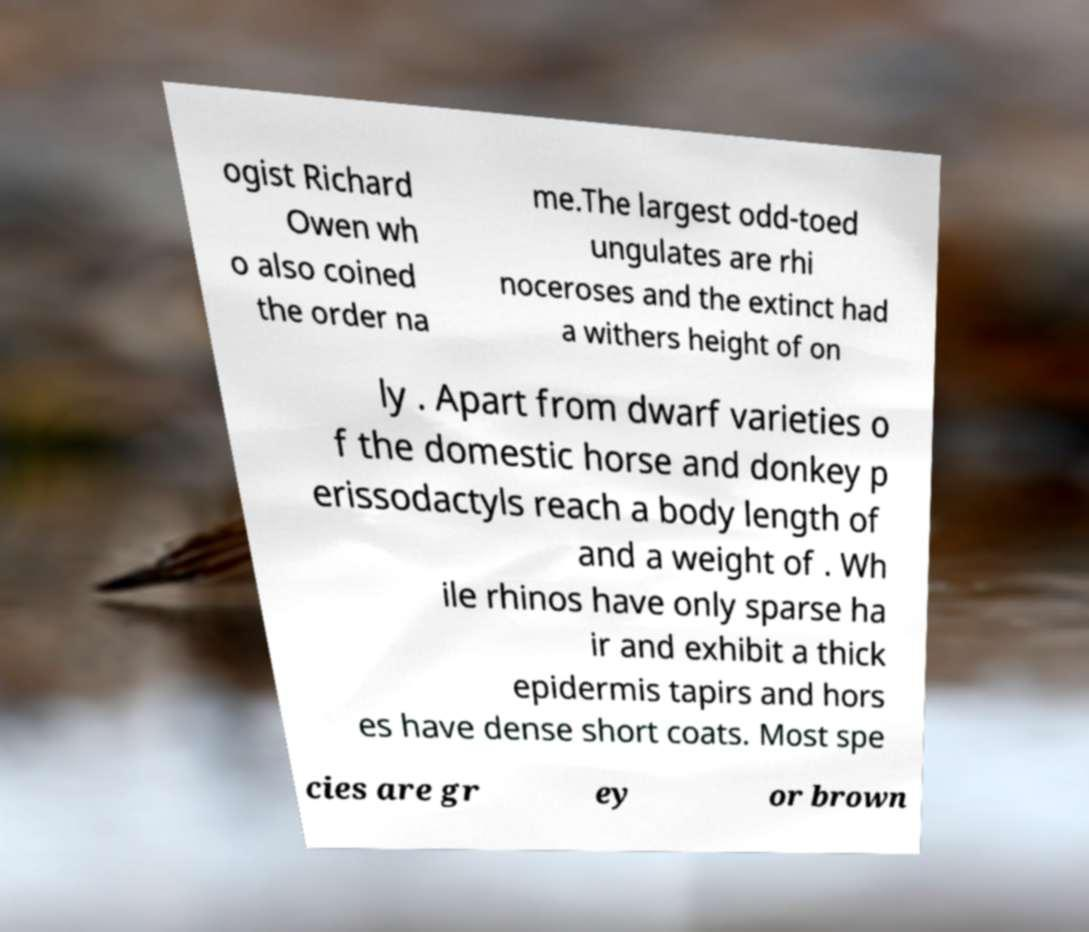Please read and relay the text visible in this image. What does it say? ogist Richard Owen wh o also coined the order na me.The largest odd-toed ungulates are rhi noceroses and the extinct had a withers height of on ly . Apart from dwarf varieties o f the domestic horse and donkey p erissodactyls reach a body length of and a weight of . Wh ile rhinos have only sparse ha ir and exhibit a thick epidermis tapirs and hors es have dense short coats. Most spe cies are gr ey or brown 